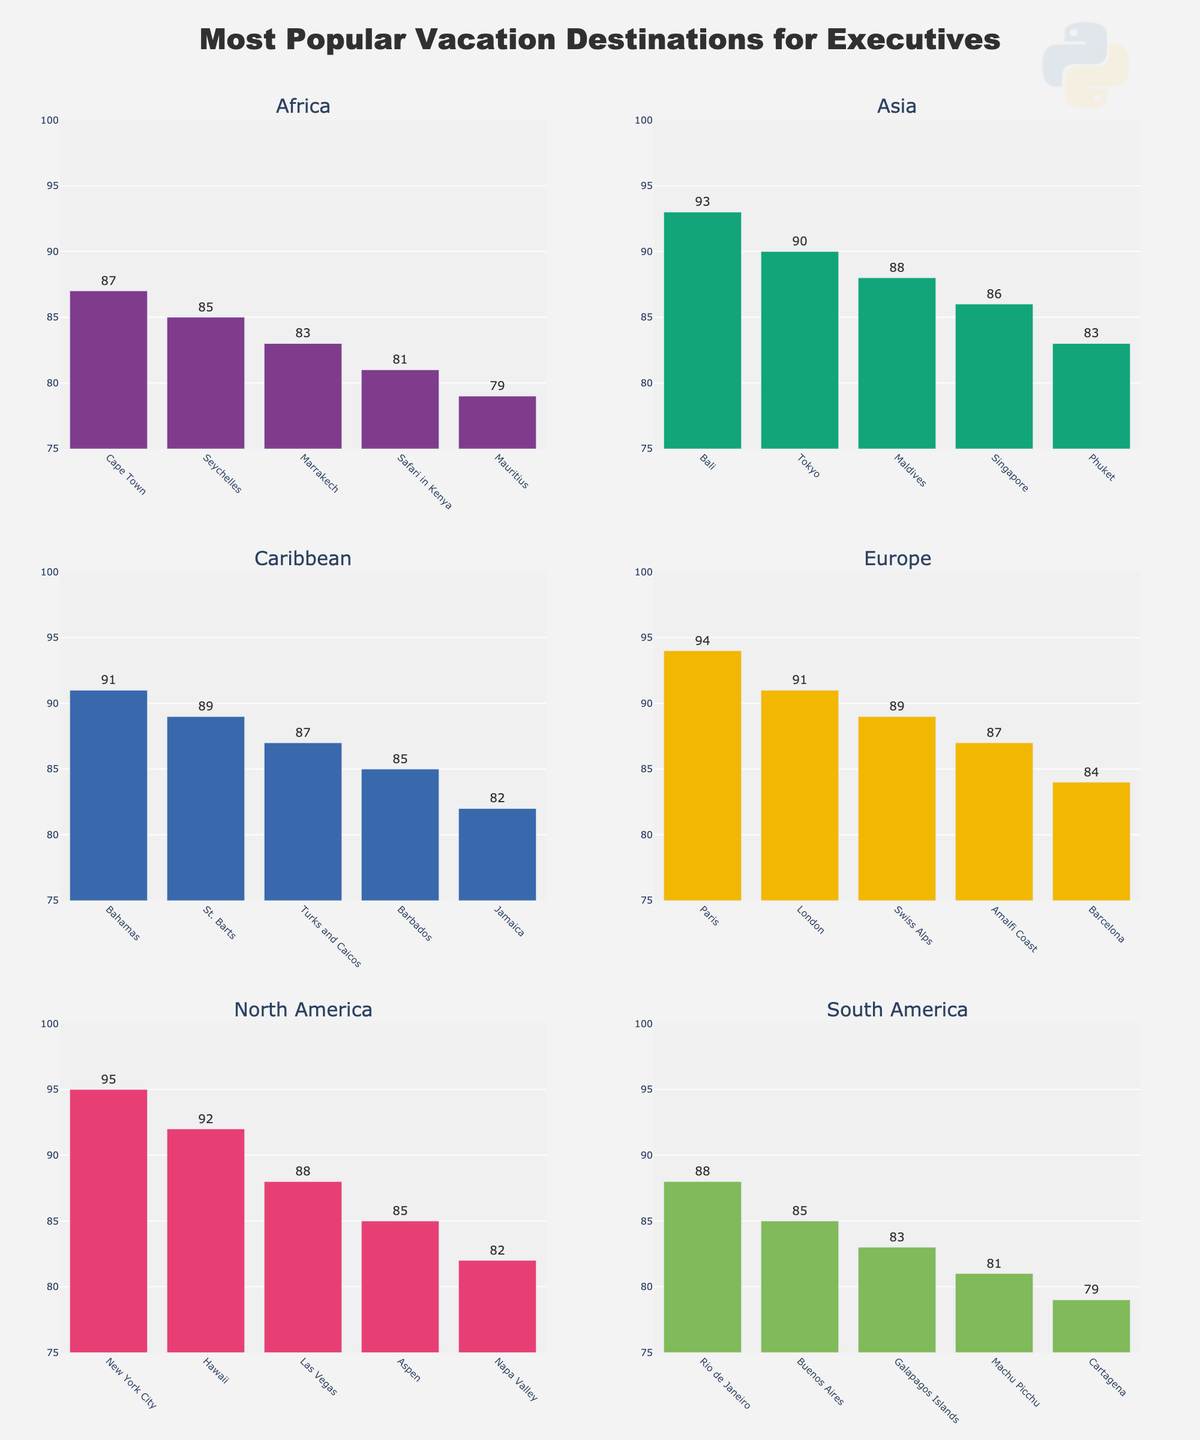Which region has the destination with the highest popularity score? The highest popularity score is 95, which belongs to New York City in North America.
Answer: North America What is the difference in popularity score between the most popular destination in North America and Europe? The most popular destination in North America is New York City with a popularity score of 95. In Europe, the most popular destination is Paris with a score of 94. The difference is 95 - 94 = 1.
Answer: 1 Compare the most popular vacation destination in Asia with the least popular destination in North America. Which one has a higher score? The most popular destination in Asia is Bali with a popularity score of 93. The least popular destination in North America is Napa Valley with a score of 82. Bali has a higher score compared to Napa Valley.
Answer: Bali Which area has the least popular vacation destination listed, and what is its score? The least popular vacation destination listed is Mauritius in the Africa region, with a popularity score of 79.
Answer: Africa, 79 Which vacation destination in the Caribbean has the same popularity score as Phuket in Asia? Phuket in Asia has a popularity score of 83. The vacation destination in the Caribbean with the same score is Jamaica.
Answer: Jamaica What is the average popularity score of the top three vacation destinations in Europe? The top three vacation destinations in Europe are Paris (94), London (91), and Swiss Alps (89). The average is calculated as (94 + 91 + 89) / 3 = 91.33.
Answer: 91.33 How many vacation destinations in South America have a popularity score above 80? The vacation destinations in South America with a popularity score above 80 are Rio de Janeiro (88), Buenos Aires (85), Galapagos Islands (83), and Machu Picchu (81). There are 4 such destinations.
Answer: 4 In which region are the popularity scores for vacation destinations most closely clustered together? We can determine the closeness by observing the range of scores within each region. North America has scores ranging from 95 to 82 (13 points), Europe from 94 to 84 (10 points), Asia from 93 to 83 (10 points), Caribbean from 91 to 82 (9 points), South America from 88 to 79 (9 points), and Africa from 87 to 79 (8 points). Africa's scores are most closely clustered with a range of 8 points.
Answer: Africa 